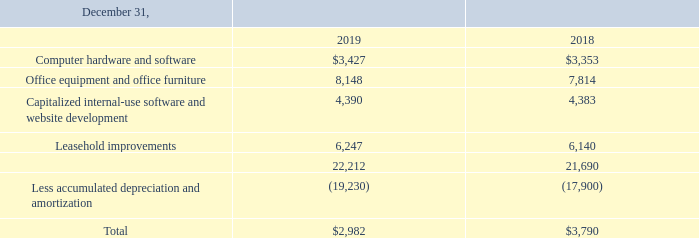Property and equipment consist of the following (in thousands):
Depreciation expense was $1.2 million and $1.6 million for the years ended December 31, 2019 and 2018, respectively.
Amortization of capitalized internal-use software and website development costs was $157,000 and $247,000 for the years ended December 31, 2019 and 2018, respectively.
What is the depreciation expense for 2019 and 2018 respectively? $1.2 million, $1.6 million. What is the amount of computer hardware and software for 2019 and 2018 respectively?
Answer scale should be: thousand. $3,427, $3,353. What is the amount of office equipment and office furniture for 2019 and 2018 respectively?
Answer scale should be: thousand. 8,148, 7,814. What is the change in the amount of computer hardware and software between 2018 and 2019?
Answer scale should be: thousand. 3,427-3,353
Answer: 74. What is the average of the total property and equipment for 2018 and 2019?
Answer scale should be: thousand. (2,982+ 3,790)/2
Answer: 3386. What is the percentage change in the leasehold improvements amount from 2018 to 2019?
Answer scale should be: percent. (6,247-6,140)/6,140
Answer: 1.74. 